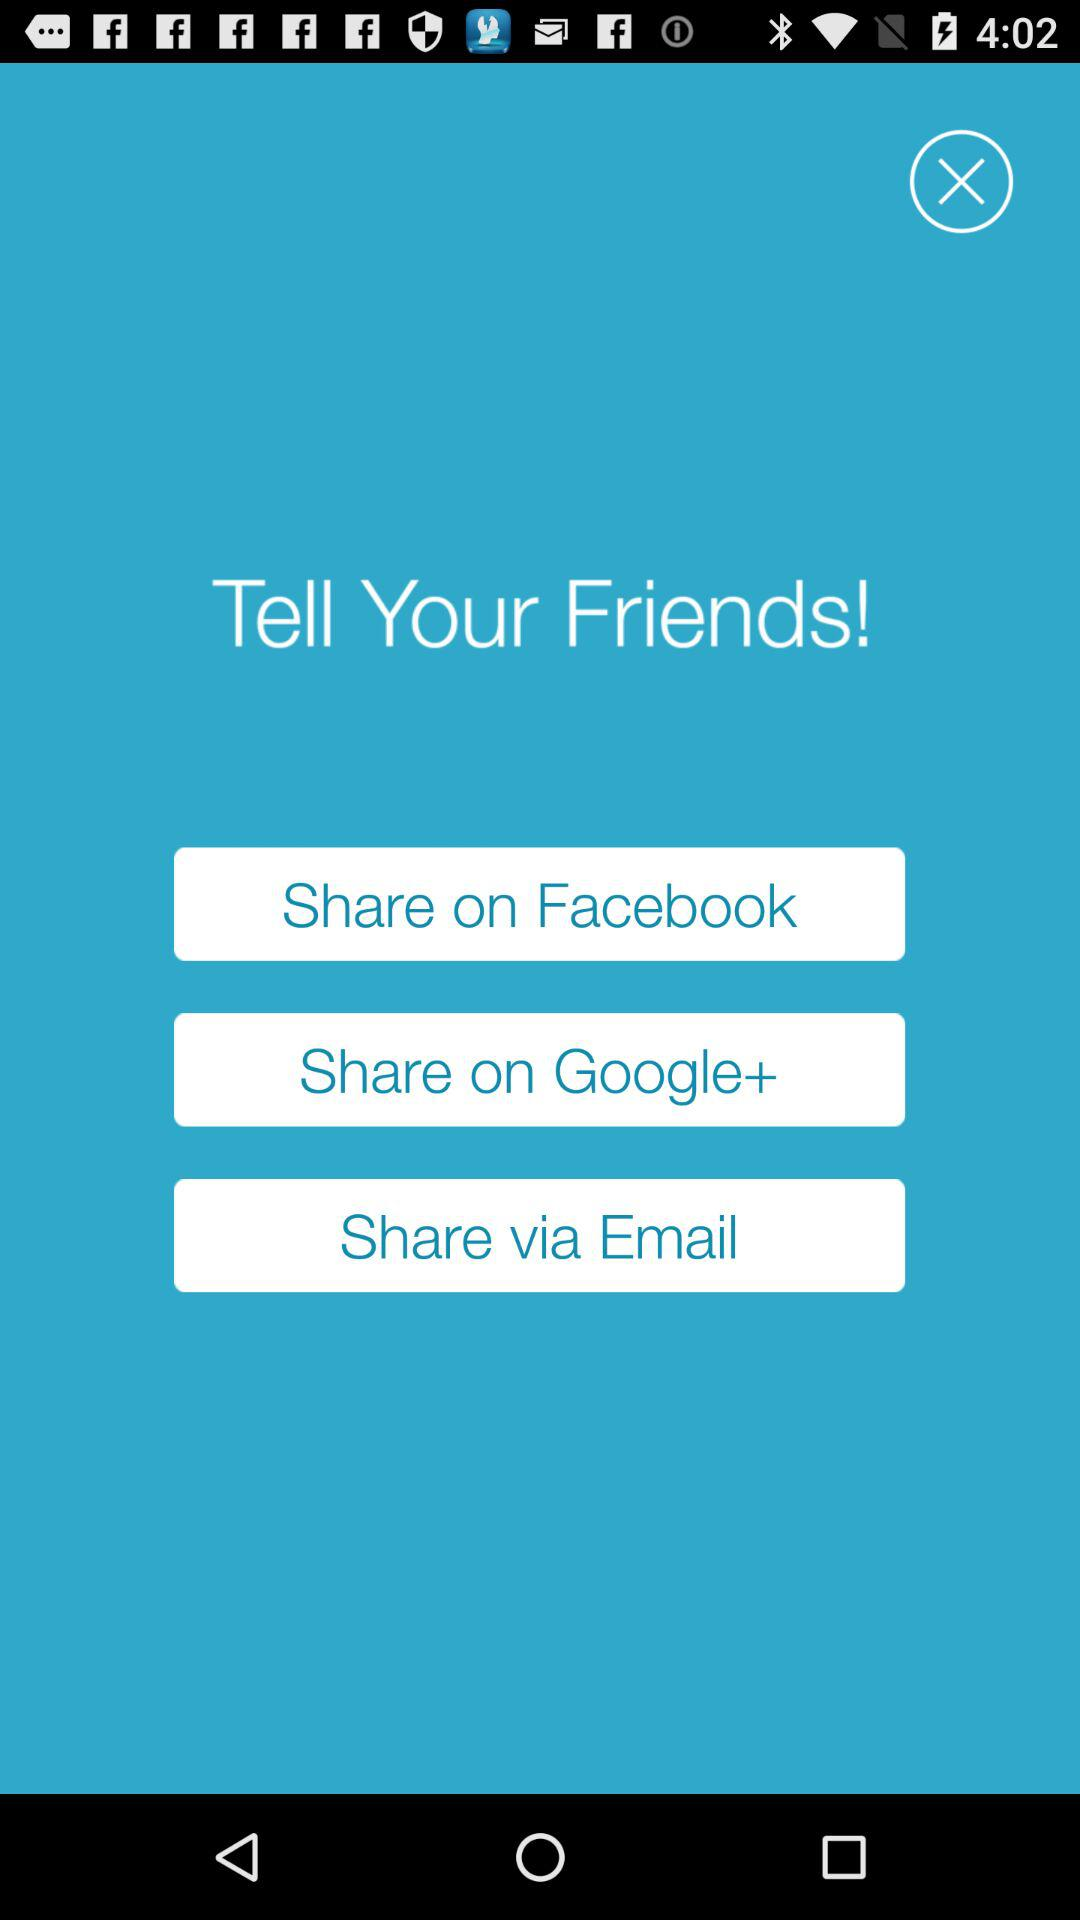What accounts can I use to share? The accounts you can use to share are "Facebook", "Google+", and "Email". 